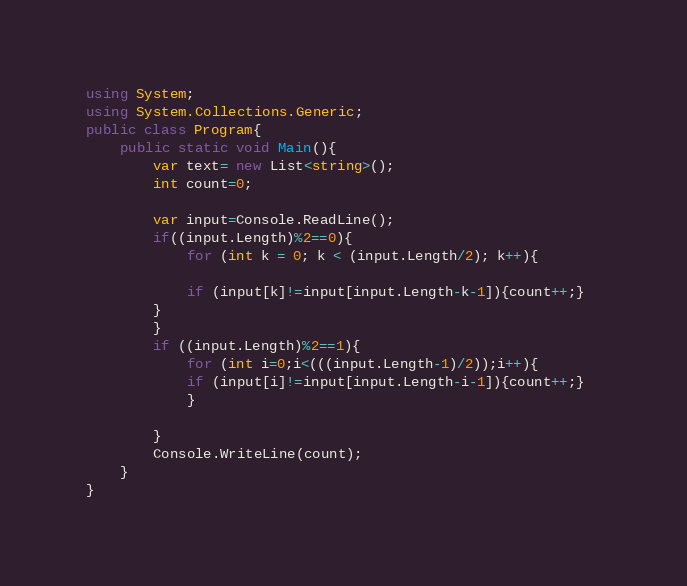<code> <loc_0><loc_0><loc_500><loc_500><_C#_>using System;
using System.Collections.Generic;
public class Program{
    public static void Main(){
        var text= new List<string>();
        int count=0;
        
        var input=Console.ReadLine();
        if((input.Length)%2==0){
            for (int k = 0; k < (input.Length/2); k++){
        
            if (input[k]!=input[input.Length-k-1]){count++;}
        }
        }
        if ((input.Length)%2==1){
            for (int i=0;i<(((input.Length-1)/2));i++){
            if (input[i]!=input[input.Length-i-1]){count++;}  
            }
            
        }
        Console.WriteLine(count);
    }
}</code> 